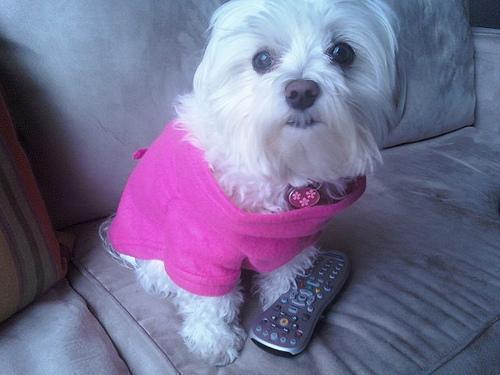What object is the item under the dog linked to?
Select the accurate response from the four choices given to answer the question.
Options: Television, computer, boombox, radio. Television. 